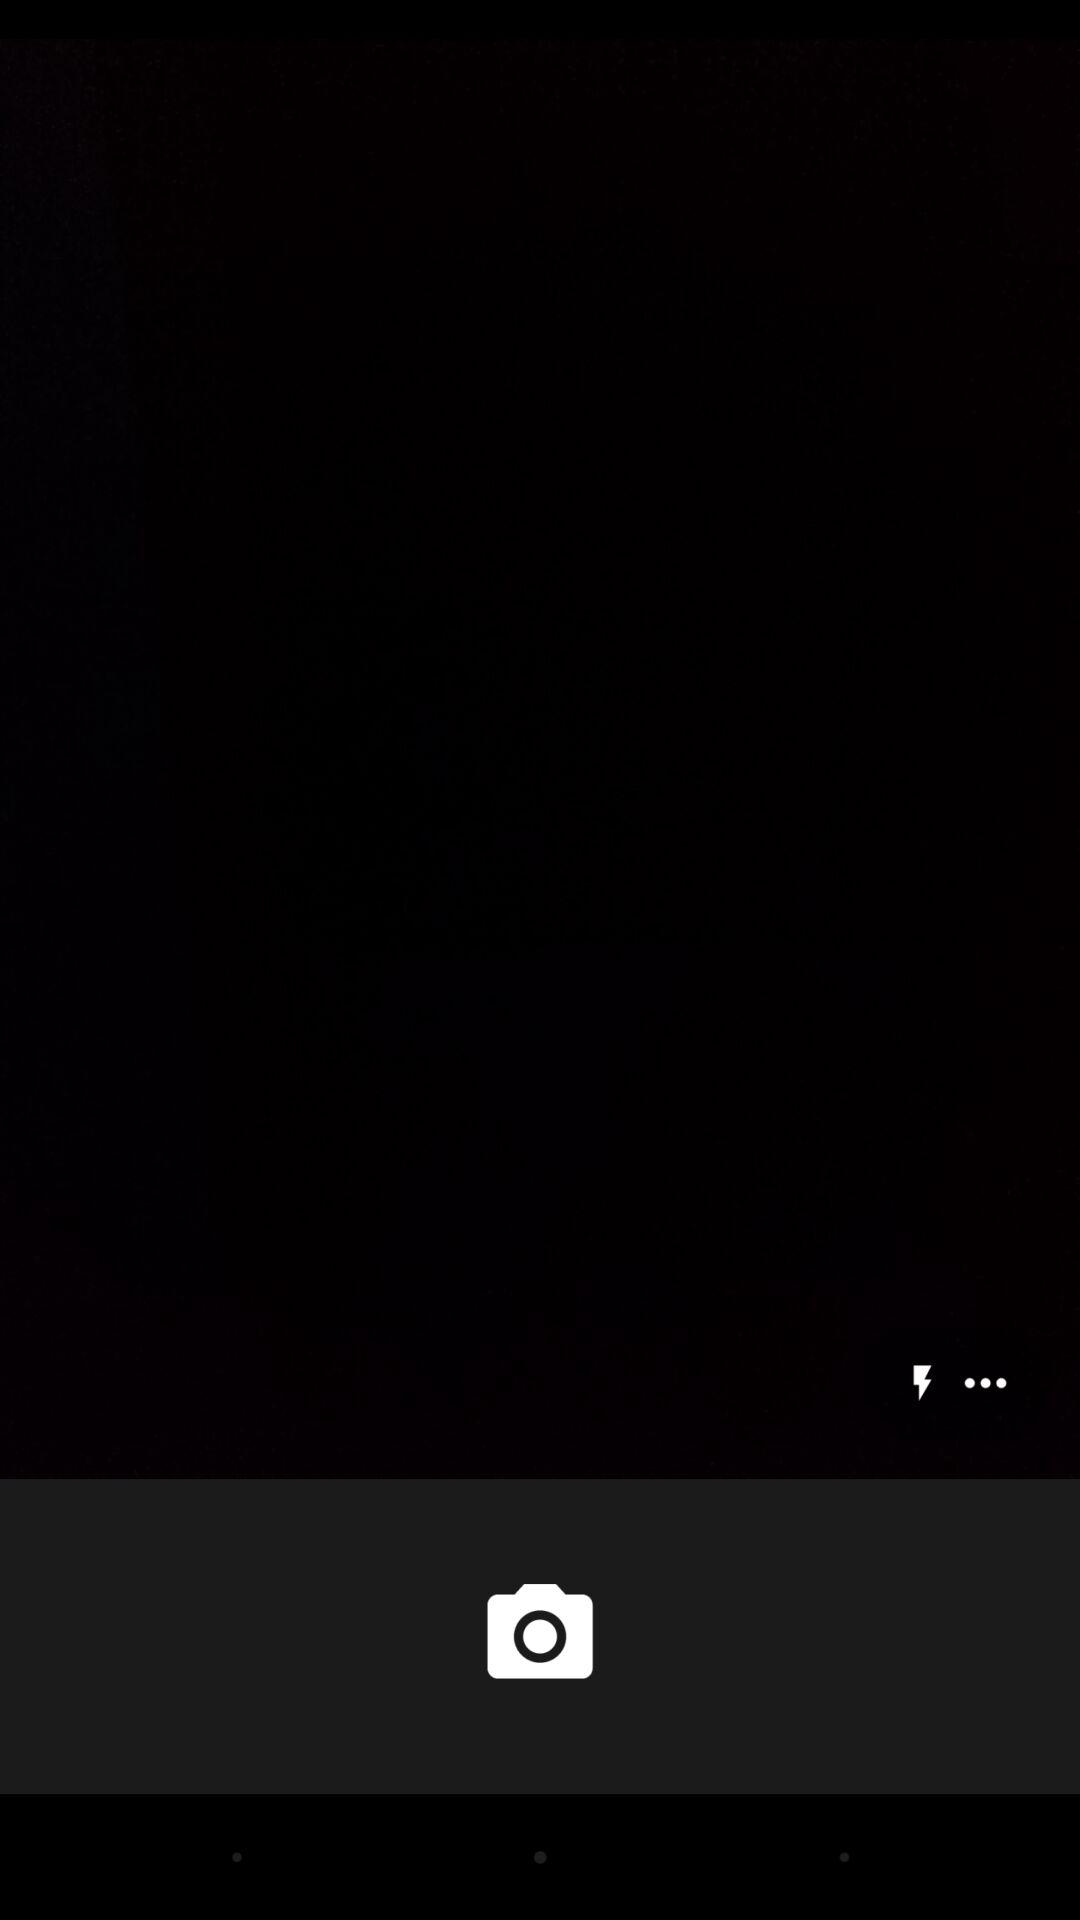How many more dots than lightning bolts are on the screen?
Answer the question using a single word or phrase. 2 